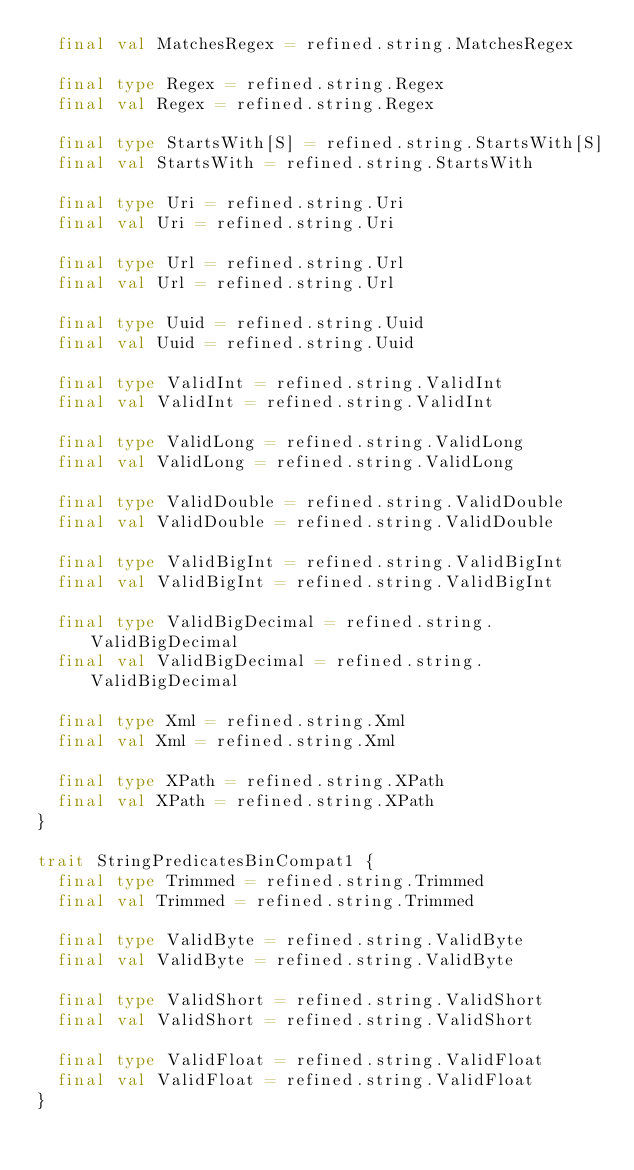<code> <loc_0><loc_0><loc_500><loc_500><_Scala_>  final val MatchesRegex = refined.string.MatchesRegex

  final type Regex = refined.string.Regex
  final val Regex = refined.string.Regex

  final type StartsWith[S] = refined.string.StartsWith[S]
  final val StartsWith = refined.string.StartsWith

  final type Uri = refined.string.Uri
  final val Uri = refined.string.Uri

  final type Url = refined.string.Url
  final val Url = refined.string.Url

  final type Uuid = refined.string.Uuid
  final val Uuid = refined.string.Uuid

  final type ValidInt = refined.string.ValidInt
  final val ValidInt = refined.string.ValidInt

  final type ValidLong = refined.string.ValidLong
  final val ValidLong = refined.string.ValidLong

  final type ValidDouble = refined.string.ValidDouble
  final val ValidDouble = refined.string.ValidDouble

  final type ValidBigInt = refined.string.ValidBigInt
  final val ValidBigInt = refined.string.ValidBigInt

  final type ValidBigDecimal = refined.string.ValidBigDecimal
  final val ValidBigDecimal = refined.string.ValidBigDecimal

  final type Xml = refined.string.Xml
  final val Xml = refined.string.Xml

  final type XPath = refined.string.XPath
  final val XPath = refined.string.XPath
}

trait StringPredicatesBinCompat1 {
  final type Trimmed = refined.string.Trimmed
  final val Trimmed = refined.string.Trimmed

  final type ValidByte = refined.string.ValidByte
  final val ValidByte = refined.string.ValidByte

  final type ValidShort = refined.string.ValidShort
  final val ValidShort = refined.string.ValidShort

  final type ValidFloat = refined.string.ValidFloat
  final val ValidFloat = refined.string.ValidFloat
}
</code> 